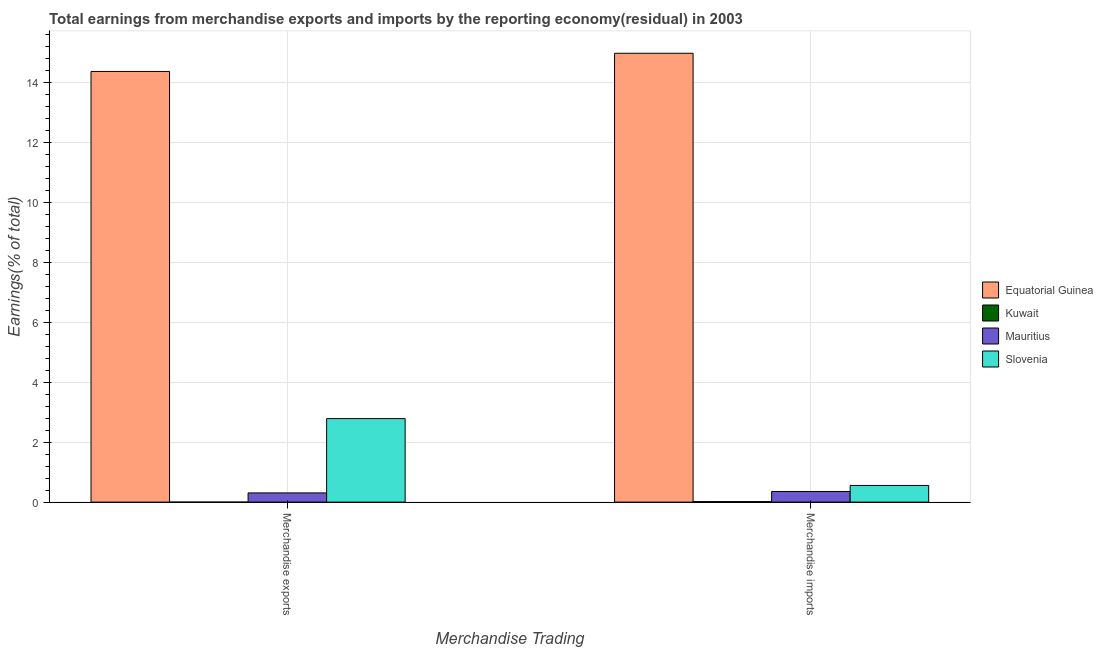Are the number of bars on each tick of the X-axis equal?
Keep it short and to the point. Yes. How many bars are there on the 1st tick from the left?
Offer a very short reply. 4. How many bars are there on the 2nd tick from the right?
Provide a succinct answer. 4. What is the label of the 2nd group of bars from the left?
Give a very brief answer. Merchandise imports. What is the earnings from merchandise exports in Kuwait?
Your response must be concise. 2.9295829641837e-9. Across all countries, what is the maximum earnings from merchandise exports?
Offer a very short reply. 14.38. Across all countries, what is the minimum earnings from merchandise exports?
Offer a terse response. 2.9295829641837e-9. In which country was the earnings from merchandise imports maximum?
Your answer should be very brief. Equatorial Guinea. In which country was the earnings from merchandise imports minimum?
Provide a short and direct response. Kuwait. What is the total earnings from merchandise imports in the graph?
Your response must be concise. 15.91. What is the difference between the earnings from merchandise exports in Equatorial Guinea and that in Mauritius?
Your answer should be compact. 14.07. What is the difference between the earnings from merchandise exports in Slovenia and the earnings from merchandise imports in Mauritius?
Ensure brevity in your answer.  2.43. What is the average earnings from merchandise imports per country?
Keep it short and to the point. 3.98. What is the difference between the earnings from merchandise imports and earnings from merchandise exports in Equatorial Guinea?
Give a very brief answer. 0.61. What is the ratio of the earnings from merchandise imports in Mauritius to that in Kuwait?
Provide a short and direct response. 19.67. Is the earnings from merchandise imports in Mauritius less than that in Kuwait?
Your response must be concise. No. What does the 1st bar from the left in Merchandise imports represents?
Make the answer very short. Equatorial Guinea. What does the 4th bar from the right in Merchandise imports represents?
Provide a short and direct response. Equatorial Guinea. How many countries are there in the graph?
Provide a short and direct response. 4. What is the difference between two consecutive major ticks on the Y-axis?
Keep it short and to the point. 2. Does the graph contain any zero values?
Give a very brief answer. No. Does the graph contain grids?
Give a very brief answer. Yes. How are the legend labels stacked?
Offer a very short reply. Vertical. What is the title of the graph?
Your answer should be very brief. Total earnings from merchandise exports and imports by the reporting economy(residual) in 2003. Does "Nepal" appear as one of the legend labels in the graph?
Keep it short and to the point. No. What is the label or title of the X-axis?
Provide a short and direct response. Merchandise Trading. What is the label or title of the Y-axis?
Your response must be concise. Earnings(% of total). What is the Earnings(% of total) of Equatorial Guinea in Merchandise exports?
Your answer should be compact. 14.38. What is the Earnings(% of total) in Kuwait in Merchandise exports?
Provide a succinct answer. 2.9295829641837e-9. What is the Earnings(% of total) in Mauritius in Merchandise exports?
Your answer should be compact. 0.31. What is the Earnings(% of total) in Slovenia in Merchandise exports?
Give a very brief answer. 2.79. What is the Earnings(% of total) of Equatorial Guinea in Merchandise imports?
Your answer should be very brief. 14.98. What is the Earnings(% of total) in Kuwait in Merchandise imports?
Your response must be concise. 0.02. What is the Earnings(% of total) of Mauritius in Merchandise imports?
Make the answer very short. 0.35. What is the Earnings(% of total) of Slovenia in Merchandise imports?
Keep it short and to the point. 0.56. Across all Merchandise Trading, what is the maximum Earnings(% of total) in Equatorial Guinea?
Ensure brevity in your answer.  14.98. Across all Merchandise Trading, what is the maximum Earnings(% of total) of Kuwait?
Give a very brief answer. 0.02. Across all Merchandise Trading, what is the maximum Earnings(% of total) in Mauritius?
Provide a succinct answer. 0.35. Across all Merchandise Trading, what is the maximum Earnings(% of total) in Slovenia?
Your response must be concise. 2.79. Across all Merchandise Trading, what is the minimum Earnings(% of total) of Equatorial Guinea?
Keep it short and to the point. 14.38. Across all Merchandise Trading, what is the minimum Earnings(% of total) in Kuwait?
Your response must be concise. 2.9295829641837e-9. Across all Merchandise Trading, what is the minimum Earnings(% of total) of Mauritius?
Your answer should be compact. 0.31. Across all Merchandise Trading, what is the minimum Earnings(% of total) in Slovenia?
Your answer should be very brief. 0.56. What is the total Earnings(% of total) of Equatorial Guinea in the graph?
Offer a terse response. 29.36. What is the total Earnings(% of total) of Kuwait in the graph?
Your answer should be very brief. 0.02. What is the total Earnings(% of total) of Mauritius in the graph?
Your answer should be very brief. 0.66. What is the total Earnings(% of total) of Slovenia in the graph?
Provide a short and direct response. 3.34. What is the difference between the Earnings(% of total) of Equatorial Guinea in Merchandise exports and that in Merchandise imports?
Your response must be concise. -0.61. What is the difference between the Earnings(% of total) of Kuwait in Merchandise exports and that in Merchandise imports?
Provide a succinct answer. -0.02. What is the difference between the Earnings(% of total) of Mauritius in Merchandise exports and that in Merchandise imports?
Make the answer very short. -0.05. What is the difference between the Earnings(% of total) of Slovenia in Merchandise exports and that in Merchandise imports?
Provide a succinct answer. 2.23. What is the difference between the Earnings(% of total) of Equatorial Guinea in Merchandise exports and the Earnings(% of total) of Kuwait in Merchandise imports?
Give a very brief answer. 14.36. What is the difference between the Earnings(% of total) of Equatorial Guinea in Merchandise exports and the Earnings(% of total) of Mauritius in Merchandise imports?
Keep it short and to the point. 14.02. What is the difference between the Earnings(% of total) of Equatorial Guinea in Merchandise exports and the Earnings(% of total) of Slovenia in Merchandise imports?
Your response must be concise. 13.82. What is the difference between the Earnings(% of total) in Kuwait in Merchandise exports and the Earnings(% of total) in Mauritius in Merchandise imports?
Offer a very short reply. -0.35. What is the difference between the Earnings(% of total) of Kuwait in Merchandise exports and the Earnings(% of total) of Slovenia in Merchandise imports?
Provide a short and direct response. -0.56. What is the difference between the Earnings(% of total) in Mauritius in Merchandise exports and the Earnings(% of total) in Slovenia in Merchandise imports?
Offer a very short reply. -0.25. What is the average Earnings(% of total) of Equatorial Guinea per Merchandise Trading?
Make the answer very short. 14.68. What is the average Earnings(% of total) in Kuwait per Merchandise Trading?
Offer a terse response. 0.01. What is the average Earnings(% of total) in Mauritius per Merchandise Trading?
Give a very brief answer. 0.33. What is the average Earnings(% of total) in Slovenia per Merchandise Trading?
Offer a terse response. 1.67. What is the difference between the Earnings(% of total) in Equatorial Guinea and Earnings(% of total) in Kuwait in Merchandise exports?
Your answer should be compact. 14.38. What is the difference between the Earnings(% of total) of Equatorial Guinea and Earnings(% of total) of Mauritius in Merchandise exports?
Provide a short and direct response. 14.07. What is the difference between the Earnings(% of total) in Equatorial Guinea and Earnings(% of total) in Slovenia in Merchandise exports?
Offer a very short reply. 11.59. What is the difference between the Earnings(% of total) in Kuwait and Earnings(% of total) in Mauritius in Merchandise exports?
Give a very brief answer. -0.31. What is the difference between the Earnings(% of total) of Kuwait and Earnings(% of total) of Slovenia in Merchandise exports?
Ensure brevity in your answer.  -2.79. What is the difference between the Earnings(% of total) of Mauritius and Earnings(% of total) of Slovenia in Merchandise exports?
Give a very brief answer. -2.48. What is the difference between the Earnings(% of total) in Equatorial Guinea and Earnings(% of total) in Kuwait in Merchandise imports?
Keep it short and to the point. 14.97. What is the difference between the Earnings(% of total) of Equatorial Guinea and Earnings(% of total) of Mauritius in Merchandise imports?
Your response must be concise. 14.63. What is the difference between the Earnings(% of total) of Equatorial Guinea and Earnings(% of total) of Slovenia in Merchandise imports?
Offer a terse response. 14.43. What is the difference between the Earnings(% of total) in Kuwait and Earnings(% of total) in Mauritius in Merchandise imports?
Give a very brief answer. -0.34. What is the difference between the Earnings(% of total) in Kuwait and Earnings(% of total) in Slovenia in Merchandise imports?
Provide a short and direct response. -0.54. What is the difference between the Earnings(% of total) in Mauritius and Earnings(% of total) in Slovenia in Merchandise imports?
Offer a terse response. -0.2. What is the ratio of the Earnings(% of total) in Equatorial Guinea in Merchandise exports to that in Merchandise imports?
Keep it short and to the point. 0.96. What is the ratio of the Earnings(% of total) in Mauritius in Merchandise exports to that in Merchandise imports?
Make the answer very short. 0.87. What is the ratio of the Earnings(% of total) in Slovenia in Merchandise exports to that in Merchandise imports?
Your answer should be very brief. 5.01. What is the difference between the highest and the second highest Earnings(% of total) of Equatorial Guinea?
Provide a short and direct response. 0.61. What is the difference between the highest and the second highest Earnings(% of total) of Kuwait?
Keep it short and to the point. 0.02. What is the difference between the highest and the second highest Earnings(% of total) in Mauritius?
Your answer should be compact. 0.05. What is the difference between the highest and the second highest Earnings(% of total) of Slovenia?
Your answer should be compact. 2.23. What is the difference between the highest and the lowest Earnings(% of total) of Equatorial Guinea?
Offer a very short reply. 0.61. What is the difference between the highest and the lowest Earnings(% of total) in Kuwait?
Keep it short and to the point. 0.02. What is the difference between the highest and the lowest Earnings(% of total) of Mauritius?
Provide a succinct answer. 0.05. What is the difference between the highest and the lowest Earnings(% of total) of Slovenia?
Offer a very short reply. 2.23. 